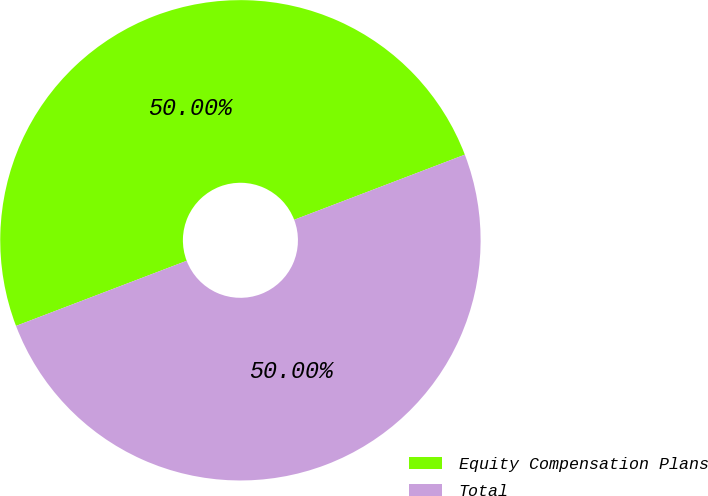Convert chart to OTSL. <chart><loc_0><loc_0><loc_500><loc_500><pie_chart><fcel>Equity Compensation Plans<fcel>Total<nl><fcel>50.0%<fcel>50.0%<nl></chart> 